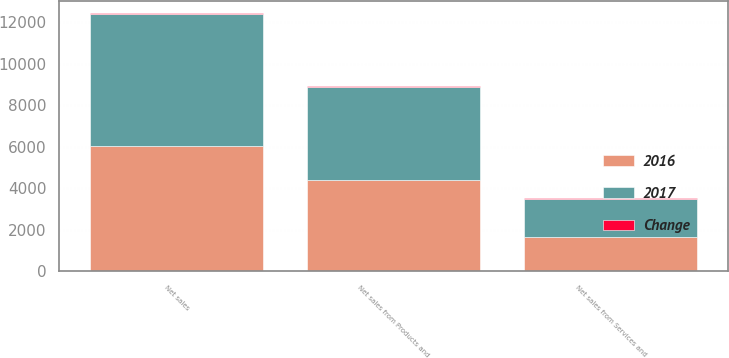<chart> <loc_0><loc_0><loc_500><loc_500><stacked_bar_chart><ecel><fcel>Net sales from Products and<fcel>Net sales from Services and<fcel>Net sales<nl><fcel>2017<fcel>4513<fcel>1867<fcel>6380<nl><fcel>2016<fcel>4394<fcel>1644<fcel>6038<nl><fcel>Change<fcel>3<fcel>14<fcel>6<nl></chart> 